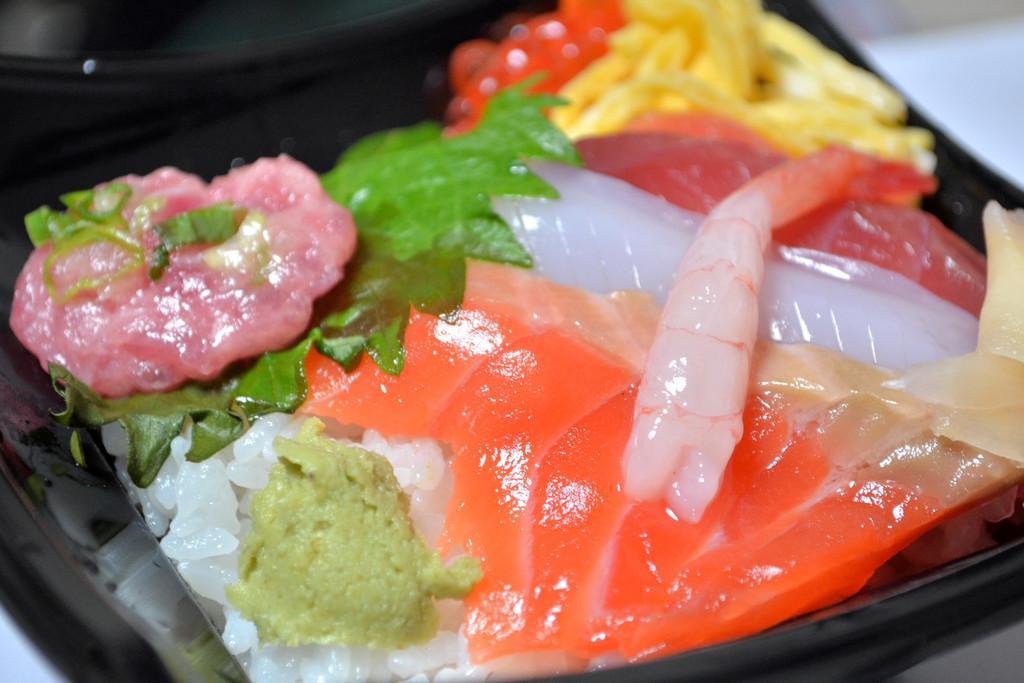How would you summarize this image in a sentence or two? It is a zoomed in picture of food item present in the black color plate which is on the white surface. 